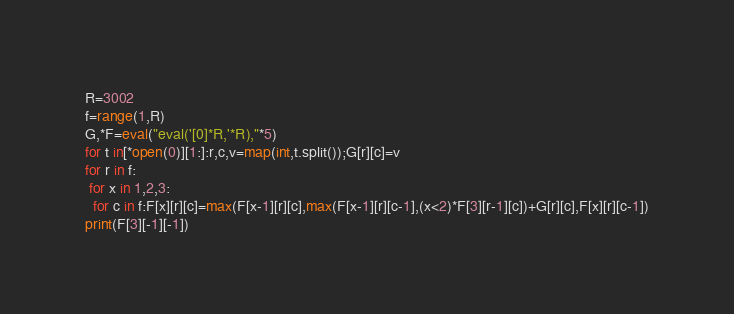<code> <loc_0><loc_0><loc_500><loc_500><_Python_>R=3002
f=range(1,R)
G,*F=eval("eval('[0]*R,'*R),"*5)
for t in[*open(0)][1:]:r,c,v=map(int,t.split());G[r][c]=v
for r in f:
 for x in 1,2,3:
  for c in f:F[x][r][c]=max(F[x-1][r][c],max(F[x-1][r][c-1],(x<2)*F[3][r-1][c])+G[r][c],F[x][r][c-1])
print(F[3][-1][-1])</code> 